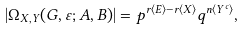Convert formula to latex. <formula><loc_0><loc_0><loc_500><loc_500>| \Omega _ { X , Y } ( G , \varepsilon ; A , B ) | = p ^ { r \langle E \rangle - r \langle X \rangle } q ^ { n \langle Y ^ { c } \rangle } ,</formula> 